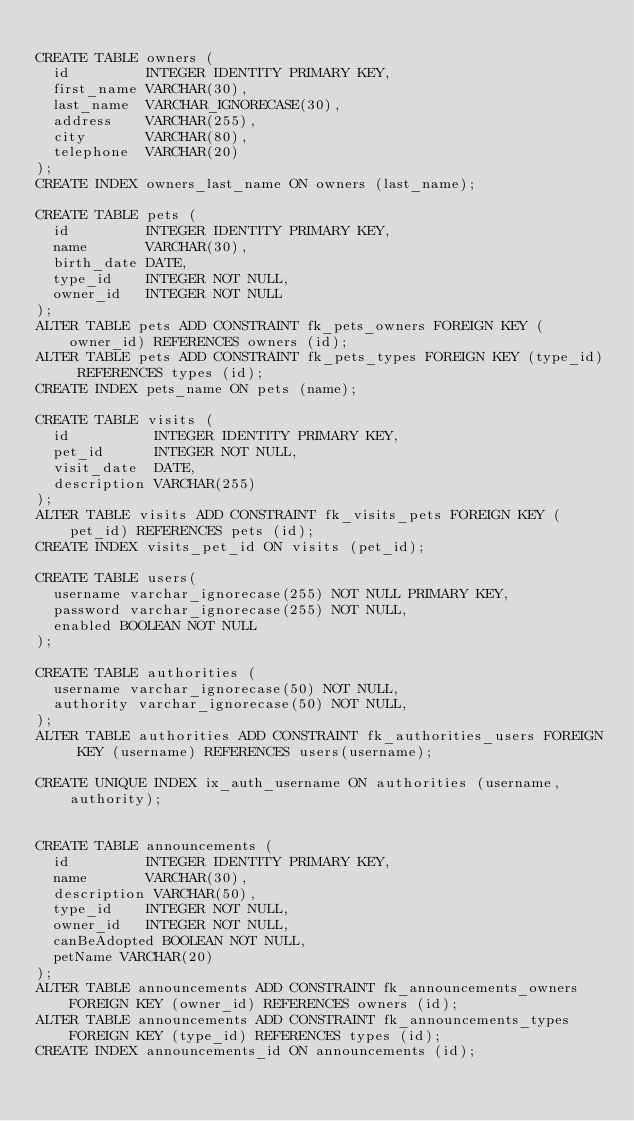<code> <loc_0><loc_0><loc_500><loc_500><_SQL_>
CREATE TABLE owners (
  id         INTEGER IDENTITY PRIMARY KEY,
  first_name VARCHAR(30),
  last_name  VARCHAR_IGNORECASE(30),
  address    VARCHAR(255),
  city       VARCHAR(80),
  telephone  VARCHAR(20)
);
CREATE INDEX owners_last_name ON owners (last_name);

CREATE TABLE pets (
  id         INTEGER IDENTITY PRIMARY KEY,
  name       VARCHAR(30),
  birth_date DATE,
  type_id    INTEGER NOT NULL,
  owner_id   INTEGER NOT NULL
);
ALTER TABLE pets ADD CONSTRAINT fk_pets_owners FOREIGN KEY (owner_id) REFERENCES owners (id);
ALTER TABLE pets ADD CONSTRAINT fk_pets_types FOREIGN KEY (type_id) REFERENCES types (id);
CREATE INDEX pets_name ON pets (name);

CREATE TABLE visits (
  id          INTEGER IDENTITY PRIMARY KEY,
  pet_id      INTEGER NOT NULL,
  visit_date  DATE,
  description VARCHAR(255)
);
ALTER TABLE visits ADD CONSTRAINT fk_visits_pets FOREIGN KEY (pet_id) REFERENCES pets (id);
CREATE INDEX visits_pet_id ON visits (pet_id);

CREATE TABLE users(
	username varchar_ignorecase(255) NOT NULL PRIMARY KEY,
	password varchar_ignorecase(255) NOT NULL,
	enabled BOOLEAN NOT NULL
);

CREATE TABLE authorities (
	username varchar_ignorecase(50) NOT NULL,
	authority varchar_ignorecase(50) NOT NULL,	
);
ALTER TABLE authorities ADD CONSTRAINT fk_authorities_users FOREIGN KEY (username) REFERENCES users(username);

CREATE UNIQUE INDEX ix_auth_username ON authorities (username,authority);


CREATE TABLE announcements (
  id         INTEGER IDENTITY PRIMARY KEY,
  name       VARCHAR(30),
  description VARCHAR(50),
  type_id    INTEGER NOT NULL,
  owner_id   INTEGER NOT NULL,
  canBeAdopted BOOLEAN NOT NULL,
  petName VARCHAR(20)
);
ALTER TABLE announcements ADD CONSTRAINT fk_announcements_owners FOREIGN KEY (owner_id) REFERENCES owners (id);
ALTER TABLE announcements ADD CONSTRAINT fk_announcements_types FOREIGN KEY (type_id) REFERENCES types (id);
CREATE INDEX announcements_id ON announcements (id);

</code> 